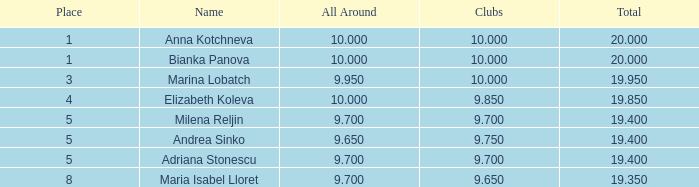How many venues feature bianka panova's name and have clubs with membership below 10? 0.0. 